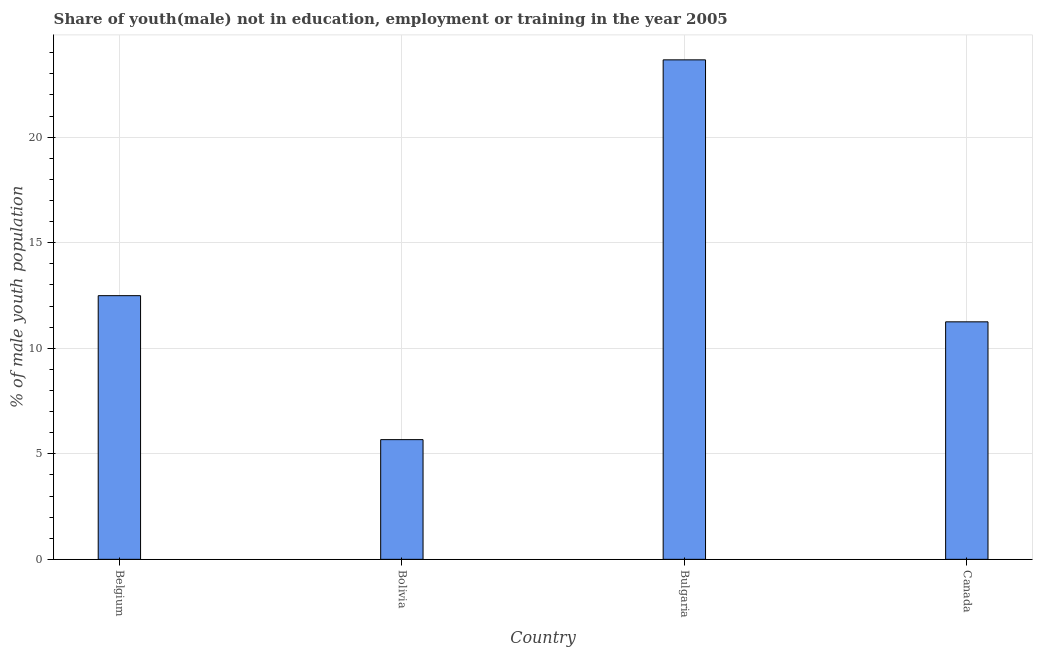What is the title of the graph?
Offer a terse response. Share of youth(male) not in education, employment or training in the year 2005. What is the label or title of the Y-axis?
Your answer should be very brief. % of male youth population. What is the unemployed male youth population in Canada?
Your response must be concise. 11.25. Across all countries, what is the maximum unemployed male youth population?
Provide a succinct answer. 23.66. Across all countries, what is the minimum unemployed male youth population?
Provide a short and direct response. 5.67. In which country was the unemployed male youth population maximum?
Ensure brevity in your answer.  Bulgaria. What is the sum of the unemployed male youth population?
Offer a terse response. 53.07. What is the difference between the unemployed male youth population in Belgium and Bulgaria?
Offer a very short reply. -11.17. What is the average unemployed male youth population per country?
Provide a short and direct response. 13.27. What is the median unemployed male youth population?
Your answer should be compact. 11.87. What is the ratio of the unemployed male youth population in Belgium to that in Bolivia?
Offer a terse response. 2.2. Is the unemployed male youth population in Belgium less than that in Canada?
Provide a succinct answer. No. Is the difference between the unemployed male youth population in Bolivia and Bulgaria greater than the difference between any two countries?
Ensure brevity in your answer.  Yes. What is the difference between the highest and the second highest unemployed male youth population?
Your answer should be very brief. 11.17. Is the sum of the unemployed male youth population in Belgium and Bolivia greater than the maximum unemployed male youth population across all countries?
Give a very brief answer. No. What is the difference between the highest and the lowest unemployed male youth population?
Your answer should be very brief. 17.99. How many bars are there?
Provide a short and direct response. 4. Are all the bars in the graph horizontal?
Ensure brevity in your answer.  No. How many countries are there in the graph?
Make the answer very short. 4. Are the values on the major ticks of Y-axis written in scientific E-notation?
Keep it short and to the point. No. What is the % of male youth population in Belgium?
Give a very brief answer. 12.49. What is the % of male youth population of Bolivia?
Ensure brevity in your answer.  5.67. What is the % of male youth population in Bulgaria?
Provide a short and direct response. 23.66. What is the % of male youth population in Canada?
Provide a short and direct response. 11.25. What is the difference between the % of male youth population in Belgium and Bolivia?
Offer a terse response. 6.82. What is the difference between the % of male youth population in Belgium and Bulgaria?
Provide a succinct answer. -11.17. What is the difference between the % of male youth population in Belgium and Canada?
Offer a very short reply. 1.24. What is the difference between the % of male youth population in Bolivia and Bulgaria?
Ensure brevity in your answer.  -17.99. What is the difference between the % of male youth population in Bolivia and Canada?
Give a very brief answer. -5.58. What is the difference between the % of male youth population in Bulgaria and Canada?
Keep it short and to the point. 12.41. What is the ratio of the % of male youth population in Belgium to that in Bolivia?
Your answer should be very brief. 2.2. What is the ratio of the % of male youth population in Belgium to that in Bulgaria?
Provide a succinct answer. 0.53. What is the ratio of the % of male youth population in Belgium to that in Canada?
Your response must be concise. 1.11. What is the ratio of the % of male youth population in Bolivia to that in Bulgaria?
Provide a short and direct response. 0.24. What is the ratio of the % of male youth population in Bolivia to that in Canada?
Your response must be concise. 0.5. What is the ratio of the % of male youth population in Bulgaria to that in Canada?
Provide a short and direct response. 2.1. 